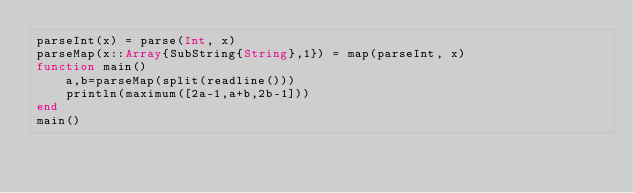<code> <loc_0><loc_0><loc_500><loc_500><_Julia_>parseInt(x) = parse(Int, x)
parseMap(x::Array{SubString{String},1}) = map(parseInt, x)
function main()
    a,b=parseMap(split(readline()))
    println(maximum([2a-1,a+b,2b-1]))
end
main()</code> 